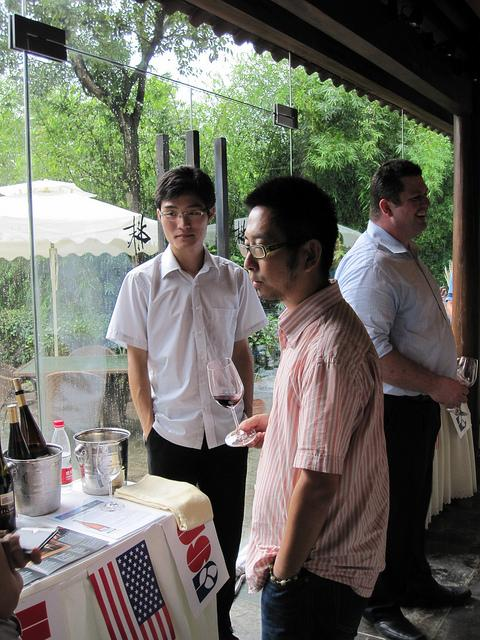What do two of the three men have on? glasses 